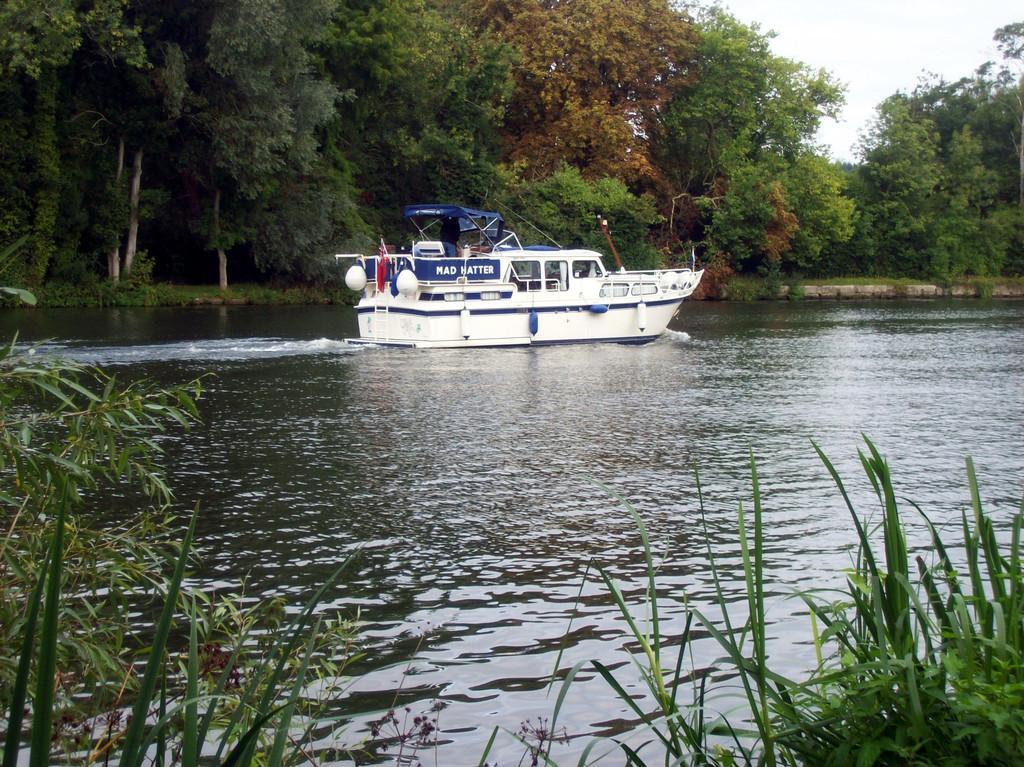In one or two sentences, can you explain what this image depicts? In this image we can see a boat on water surface. In the background of the image there are trees. At the bottom of the image there is grass. At the top of the image there is sky. 